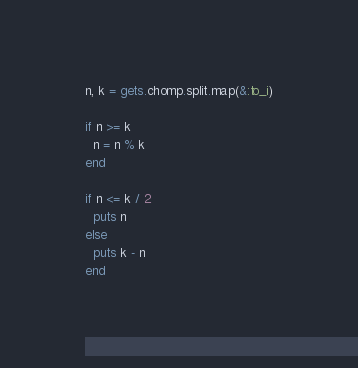<code> <loc_0><loc_0><loc_500><loc_500><_Ruby_>n, k = gets.chomp.split.map(&:to_i)

if n >= k
  n = n % k
end

if n <= k / 2
  puts n
else
  puts k - n
end</code> 